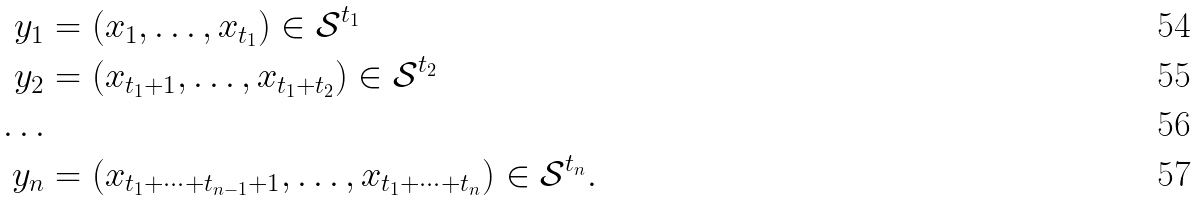Convert formula to latex. <formula><loc_0><loc_0><loc_500><loc_500>y _ { 1 } & = ( x _ { 1 } , \dots , x _ { t _ { 1 } } ) \in \mathcal { S } ^ { t _ { 1 } } \\ y _ { 2 } & = ( x _ { t _ { 1 } + 1 } , \dots , x _ { t _ { 1 } + t _ { 2 } } ) \in \mathcal { S } ^ { t _ { 2 } } \\ \dots \\ y _ { n } & = ( x _ { t _ { 1 } + \dots + t _ { n - 1 } + 1 } , \dots , x _ { t _ { 1 } + \dots + t _ { n } } ) \in \mathcal { S } ^ { t _ { n } } .</formula> 